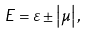<formula> <loc_0><loc_0><loc_500><loc_500>E = \varepsilon \pm \left | \mu \right | ,</formula> 